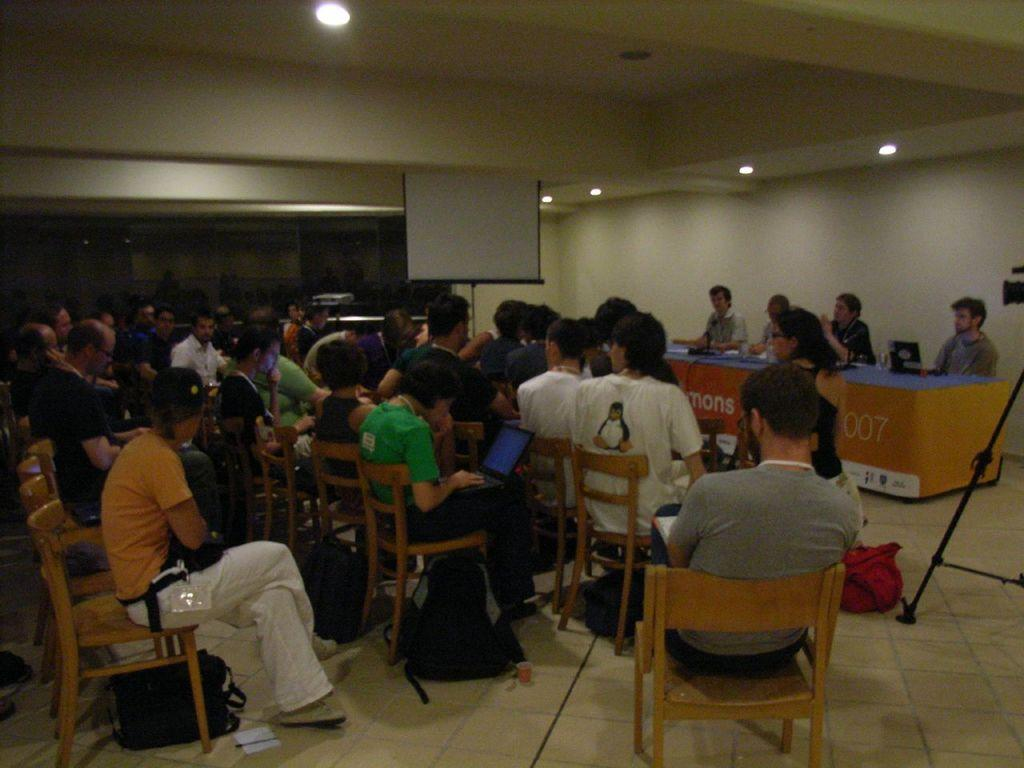What are the people in the image doing? The people in the image are sitting on chairs. Where are the people sitting in the image? The people are sitting in the right corner. What is displayed at the back of the image? There is a projector display at the back. What can be seen at the top of the image? There are lights visible at the top. What time of day is it in the image, considering the presence of the afternoon sun? There is no mention of the sun or any specific time of day in the image, so it cannot be determined from the image alone. 